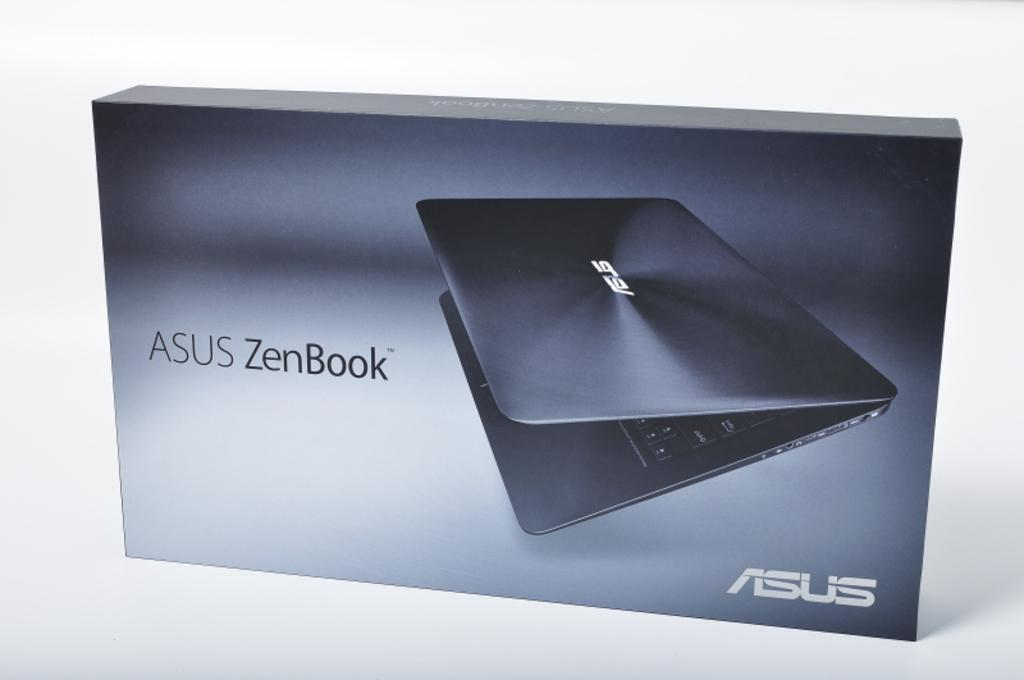<image>
Provide a brief description of the given image. A box of Zenbook from Asus with a white background. 